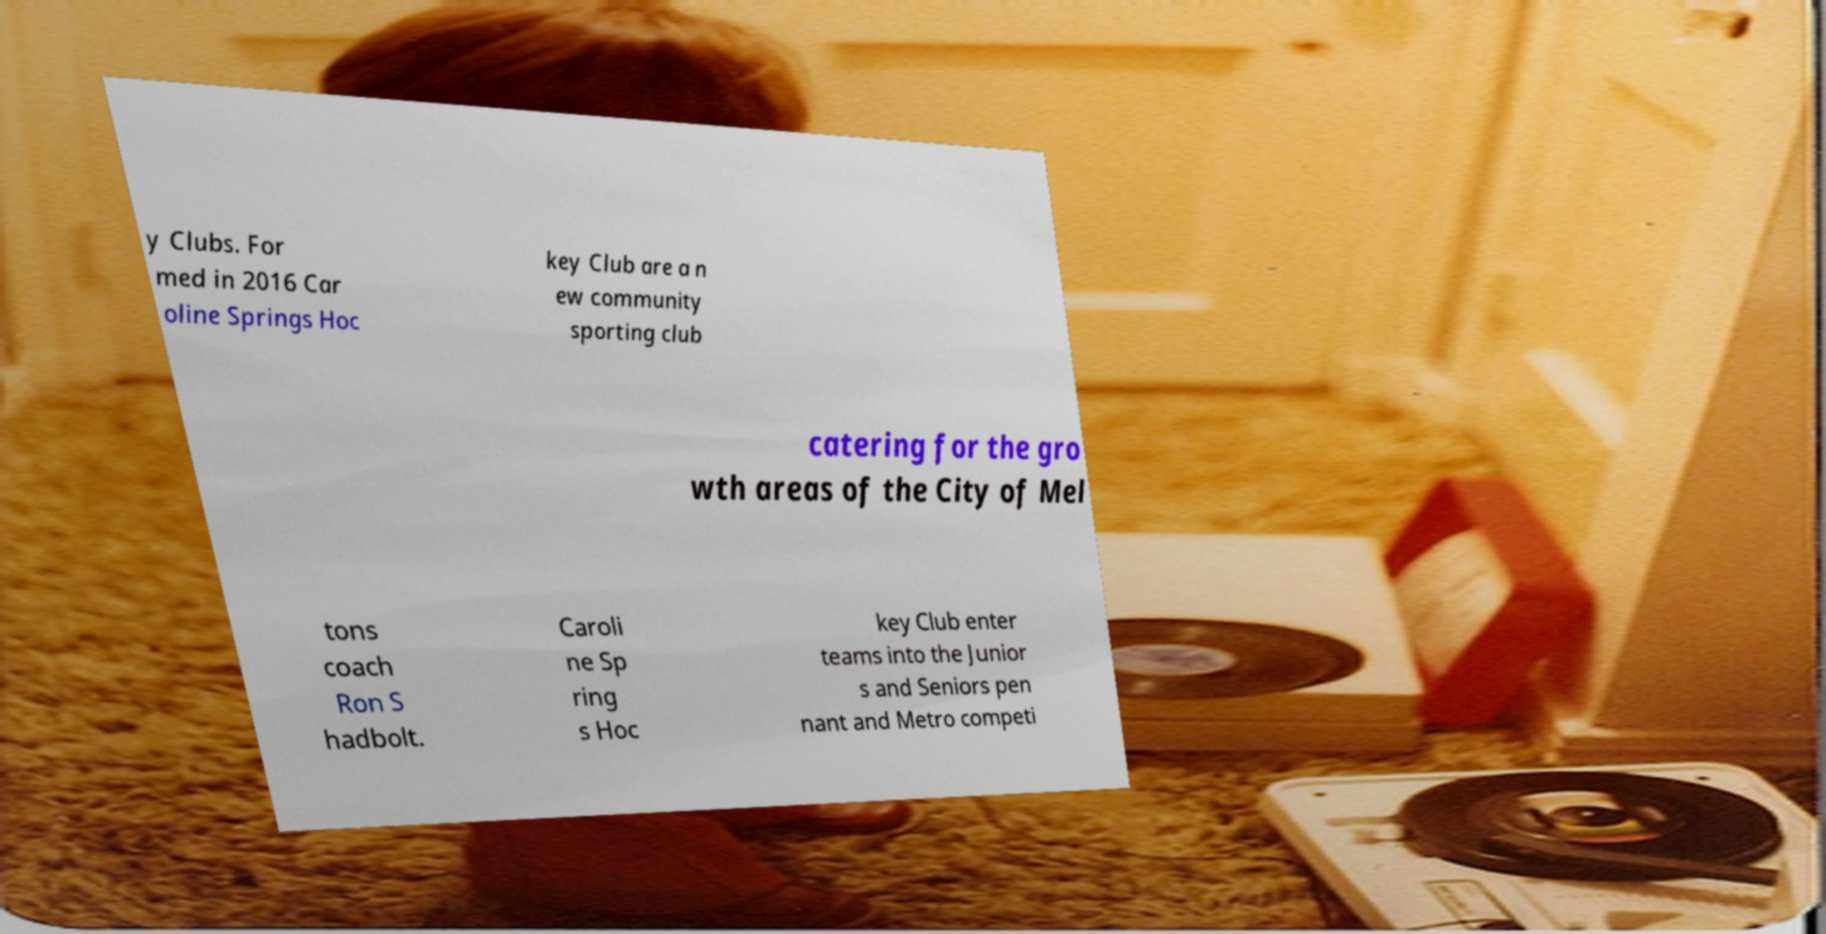Could you extract and type out the text from this image? y Clubs. For med in 2016 Car oline Springs Hoc key Club are a n ew community sporting club catering for the gro wth areas of the City of Mel tons coach Ron S hadbolt. Caroli ne Sp ring s Hoc key Club enter teams into the Junior s and Seniors pen nant and Metro competi 